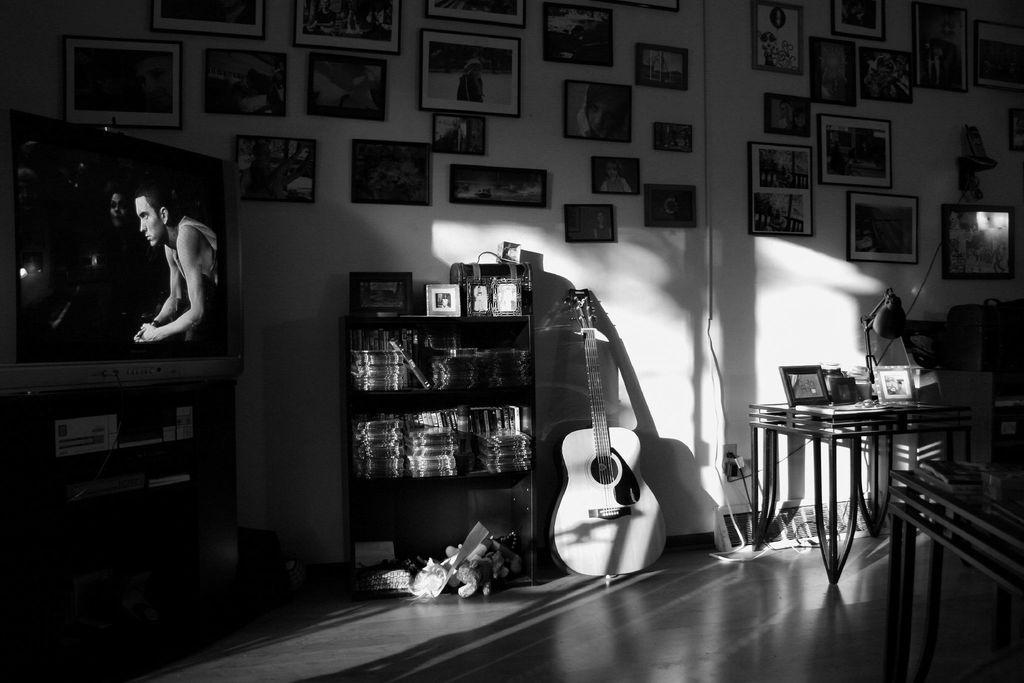Describe this image in one or two sentences. In this picture there are books in the cupboard and there are frames and objects on the table and there is a guitar. On the right side of the image there are frames, books and there is a lamp on the tables. On the left side of the image there is a television on the table and there is a picture of a person on the television. At the back there are frames on the all. At the bottom there are toys on the floor. 